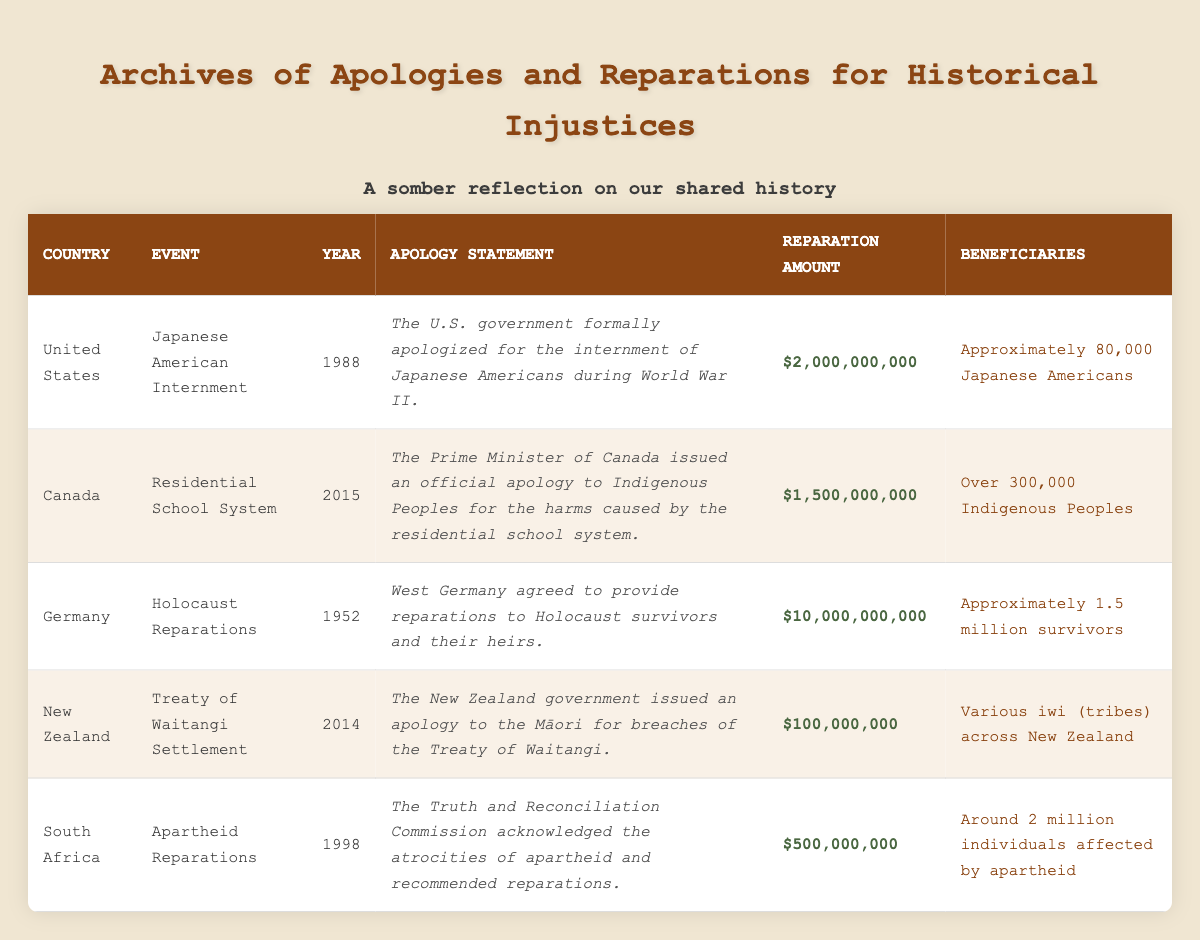What event did the United States apologize for in 1988? In the table, we can find the row for the United States, which details that in the year 1988, the apology was for the "Japanese American Internment."
Answer: Japanese American Internment How much did Germany allocate for Holocaust reparations in 1952? By looking at the row for Germany in the year 1952, we see the reparation amount listed is $10,000,000,000.
Answer: $10,000,000,000 Did South Africa issue an apology related to apartheid? In the table, South Africa's entry states that the Truth and Reconciliation Commission acknowledged the atrocities of apartheid and recommended reparations, which indicates a formal acknowledgment, thus yes, an apology was involved.
Answer: Yes What is the total reparation amount for the events listed in Canada and New Zealand? From the table, we extract the reparation amounts: Canada is $1,500,000,000 and New Zealand is $100,000,000. Adding these gives a total of $1,500,000,000 + $100,000,000 = $1,600,000,000.
Answer: $1,600,000,000 How many total beneficiaries received reparations from the Japan American Internment and Apartheid events combined? The beneficiaries for the Japanese American Internment is approximately 80,000, while for Apartheid in South Africa it is around 2,000,000. The sum would be 80,000 + 2,000,000 = 2,080,000 beneficiaries in total.
Answer: 2,080,000 Which country apologized to Indigenous Peoples for their residential school system? In the table, Canada is listed as issuing an apology to Indigenous Peoples for the harms caused by the residential school system. Therefore, Canada is the nation in question.
Answer: Canada What year did the Truth and Reconciliation Commission acknowledge apartheid atrocities? Referring to the South Africa row, we find that the acknowledgment of apartheid atrocities took place in the year 1998, as indicated in the table.
Answer: 1998 Is the reparation amount for the Treaty of Waitangi Settlement higher than the amount for the Japanese American Internment? According to the table, the reparation amount for the Treaty of Waitangi Settlement is $100,000,000, while for the Japanese American Internment, it is $2,000,000,000. Since $100,000,000 is not higher than $2,000,000,000, the answer is no.
Answer: No 